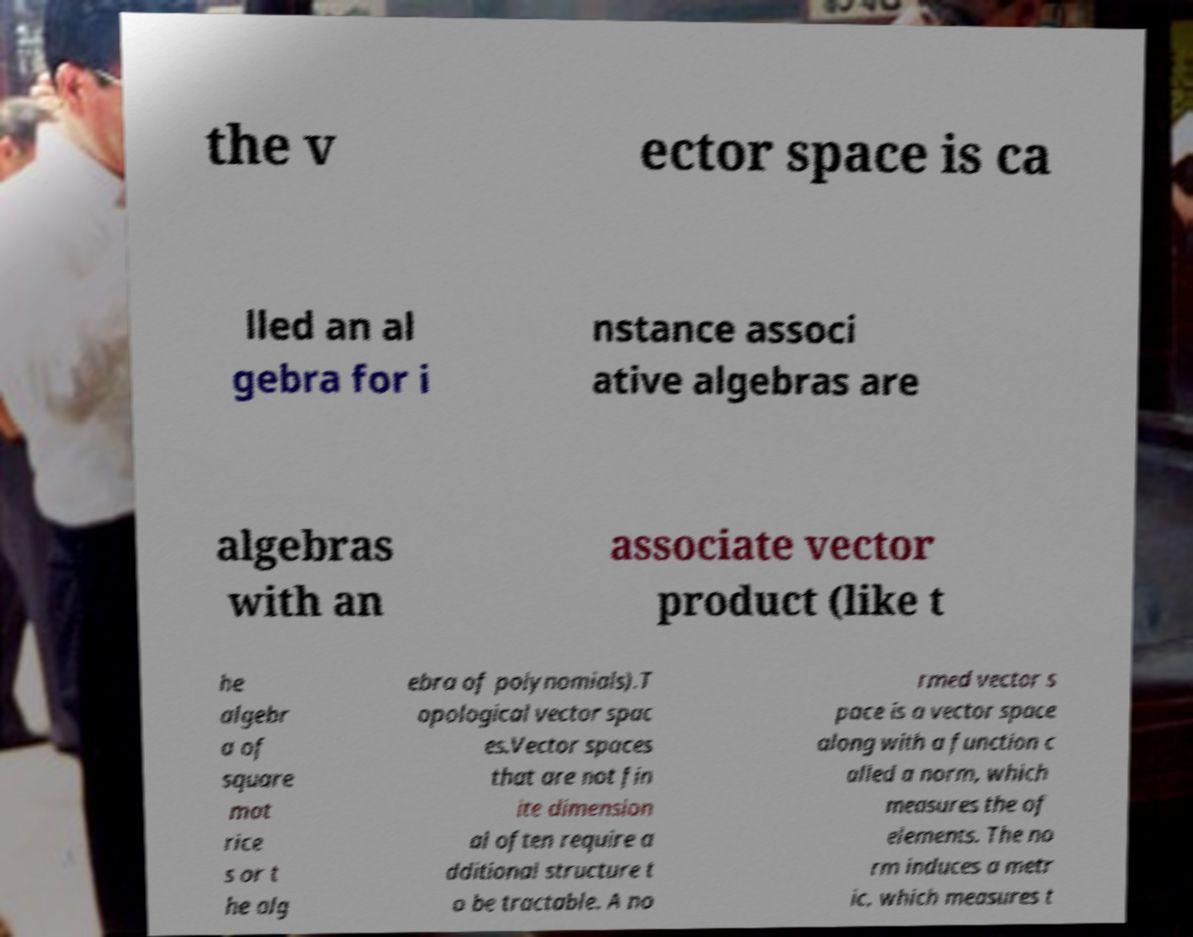I need the written content from this picture converted into text. Can you do that? the v ector space is ca lled an al gebra for i nstance associ ative algebras are algebras with an associate vector product (like t he algebr a of square mat rice s or t he alg ebra of polynomials).T opological vector spac es.Vector spaces that are not fin ite dimension al often require a dditional structure t o be tractable. A no rmed vector s pace is a vector space along with a function c alled a norm, which measures the of elements. The no rm induces a metr ic, which measures t 